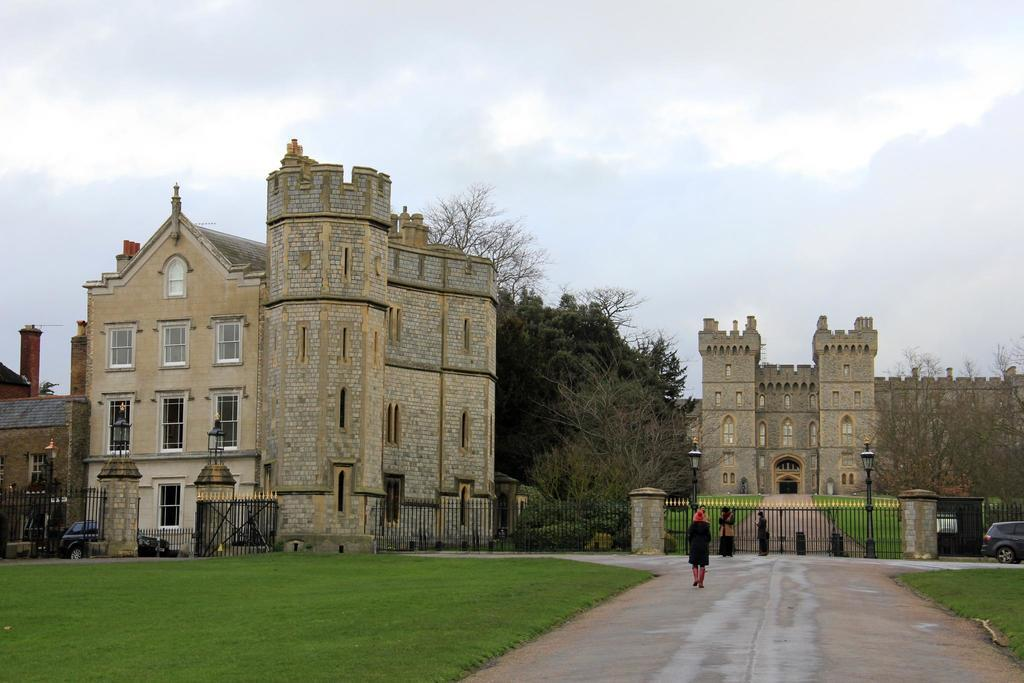What can be seen on the road in the image? There are people on the road in the image. What type of structures can be seen in the image? There are buildings visible in the image. What type of vegetation is present in the image? Trees and grass are visible in the image. What type of barrier is present in the image? There is fencing in the image. What else is present on the road in the image? Vehicles are present in the image. How many heads are visible on the rod in the image? There is no rod or head present in the image. What type of plot is being developed in the image? There is no plot being developed in the image; it features people, buildings, trees, grass, fencing, and vehicles. 